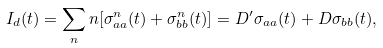Convert formula to latex. <formula><loc_0><loc_0><loc_500><loc_500>I _ { d } ( t ) = \sum _ { n } n [ \sigma _ { a a } ^ { n } ( t ) + \sigma _ { b b } ^ { n } ( t ) ] = D ^ { \prime } \sigma _ { a a } ( t ) + D \sigma _ { b b } ( t ) ,</formula> 